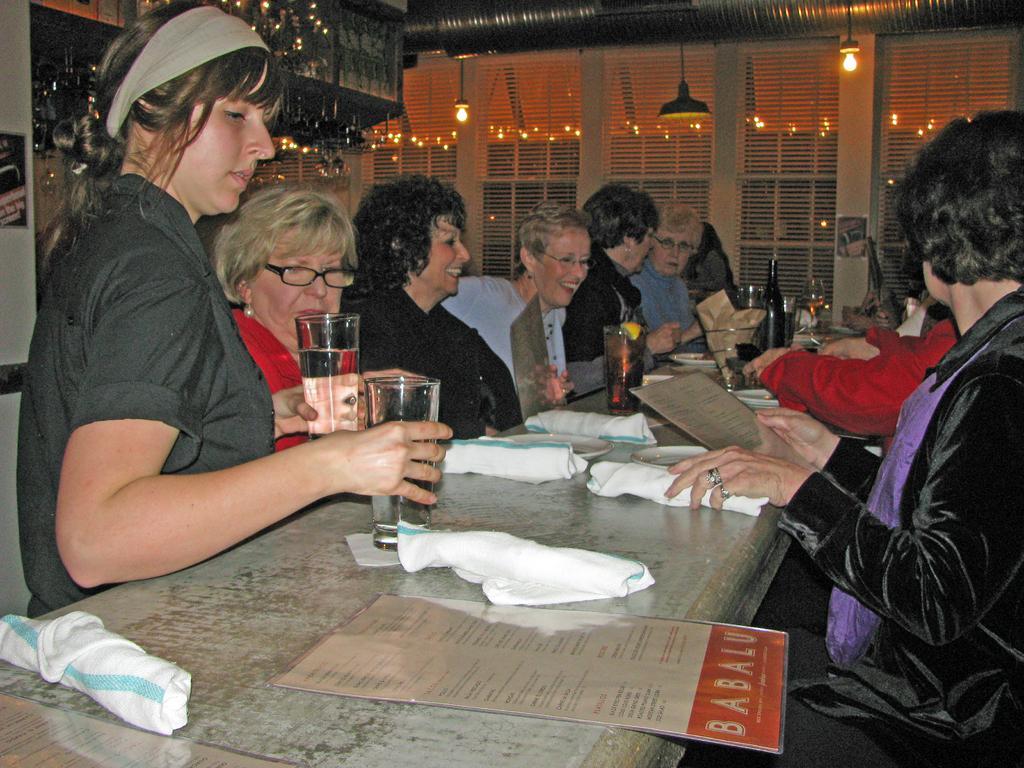Describe this image in one or two sentences. In this image there are people sitting on the chairs. In front of them there is a table and on top of the table there are menu cards, glasses, clothes, bottles and a few other objects. On top of the image there are lights. On the left side of the image there are chandeliers. 